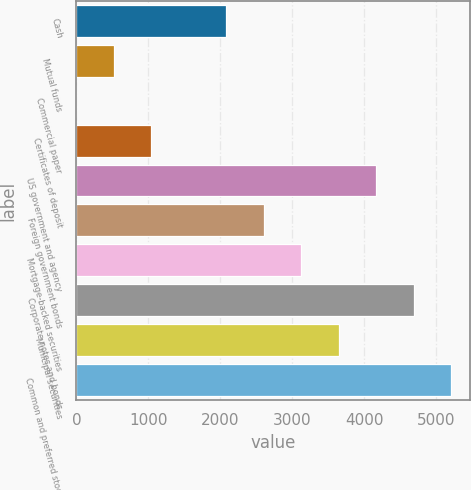Convert chart. <chart><loc_0><loc_0><loc_500><loc_500><bar_chart><fcel>Cash<fcel>Mutual funds<fcel>Commercial paper<fcel>Certificates of deposit<fcel>US government and agency<fcel>Foreign government bonds<fcel>Mortgage-backed securities<fcel>Corporate notes and bonds<fcel>Municipal securities<fcel>Common and preferred stock<nl><fcel>2082.9<fcel>520.83<fcel>0.14<fcel>1041.52<fcel>4165.66<fcel>2603.59<fcel>3124.28<fcel>4686.35<fcel>3644.97<fcel>5207.04<nl></chart> 